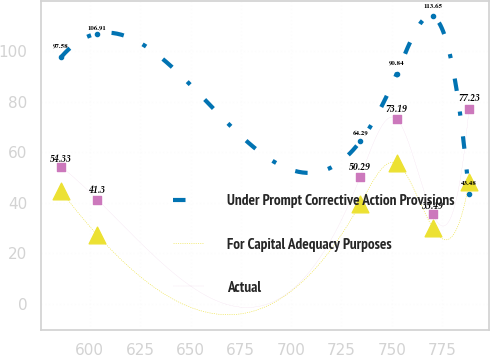Convert chart. <chart><loc_0><loc_0><loc_500><loc_500><line_chart><ecel><fcel>Under Prompt Corrective Action Provisions<fcel>For Capital Adequacy Purposes<fcel>Actual<nl><fcel>585.7<fcel>97.58<fcel>44.57<fcel>54.33<nl><fcel>603.72<fcel>106.91<fcel>27.26<fcel>41.3<nl><fcel>734.31<fcel>64.29<fcel>39.66<fcel>50.29<nl><fcel>752.33<fcel>90.84<fcel>55.63<fcel>73.19<nl><fcel>770.35<fcel>113.65<fcel>30.1<fcel>35.49<nl><fcel>788.37<fcel>43.48<fcel>48.17<fcel>77.23<nl></chart> 